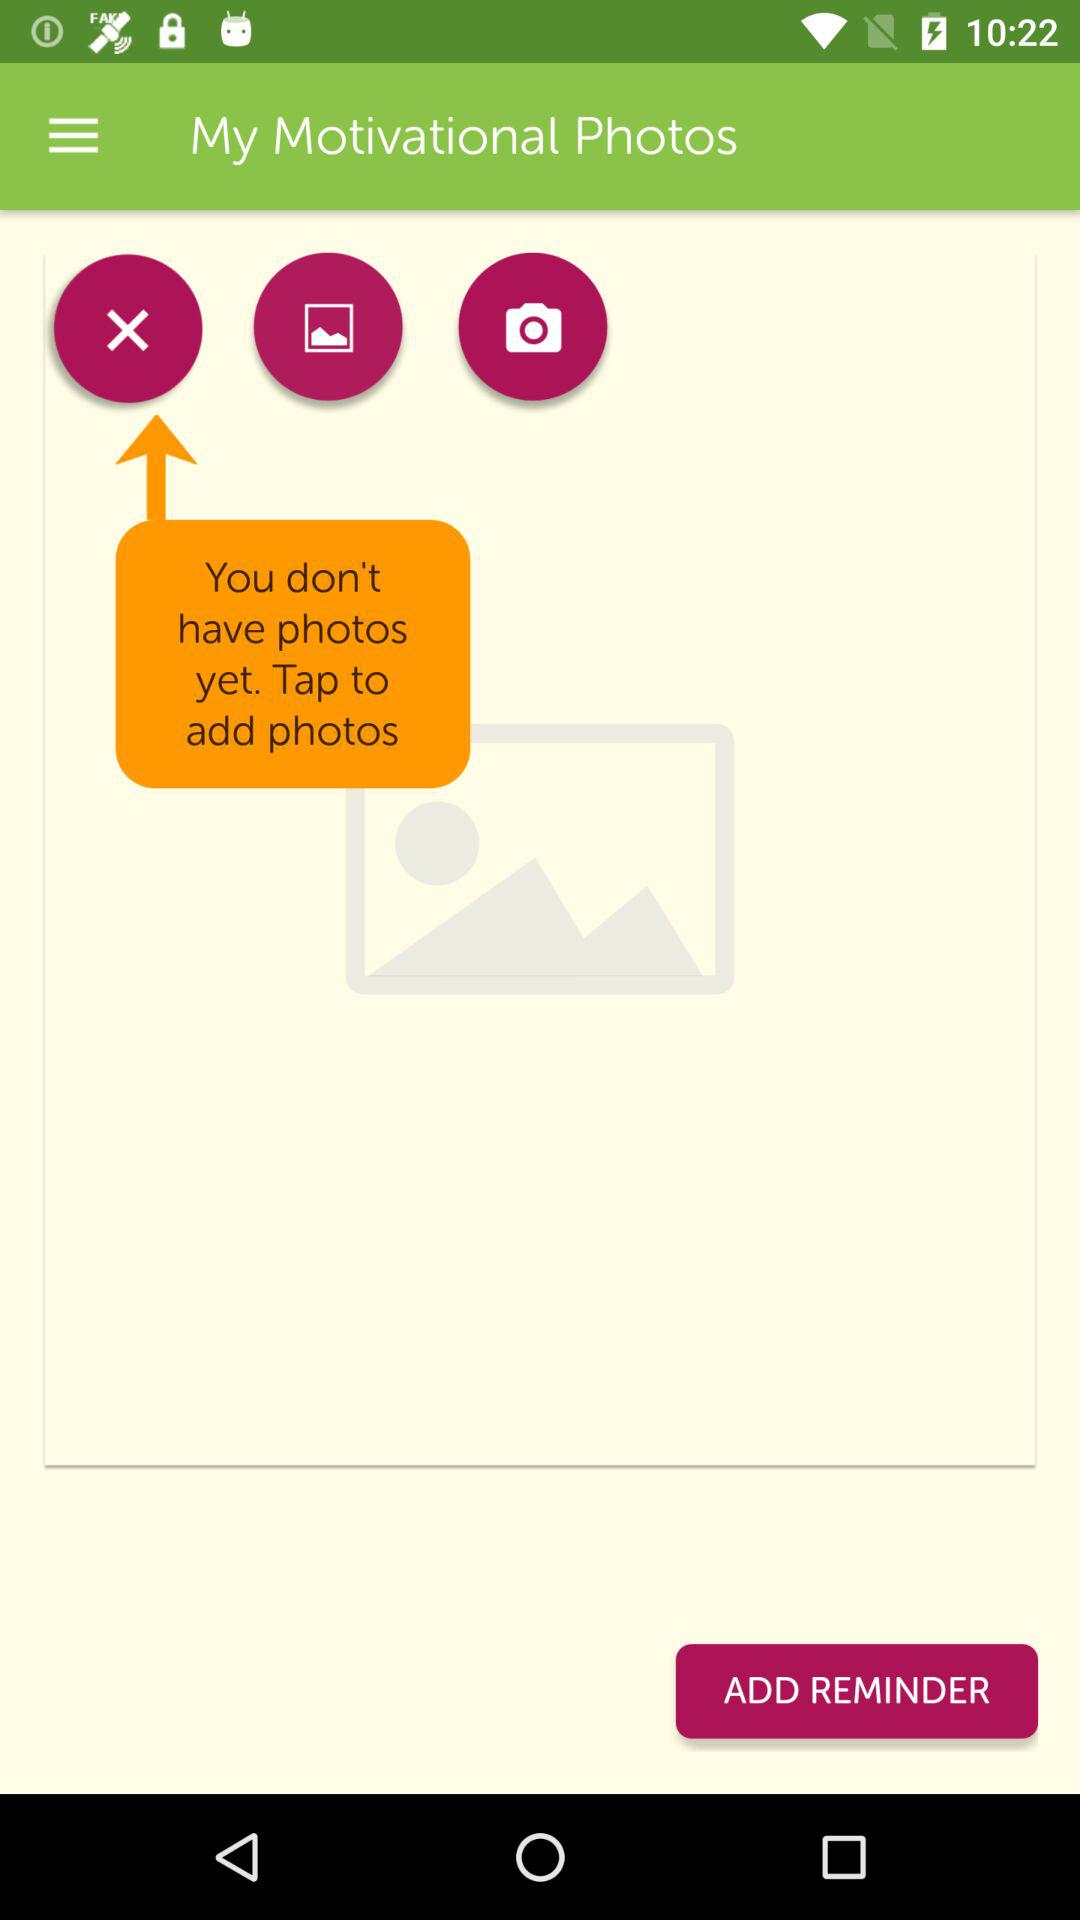How many photos are there?
Answer the question using a single word or phrase. 0 